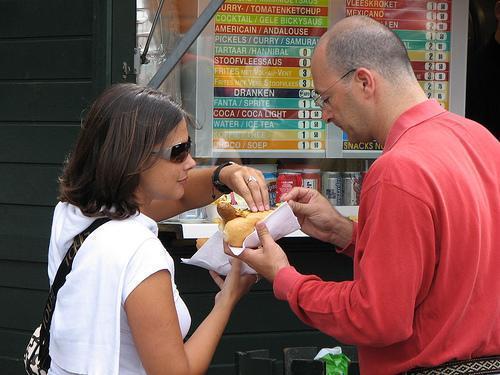How many people are in the picture?
Give a very brief answer. 2. How many purses are in the picture?
Give a very brief answer. 1. 